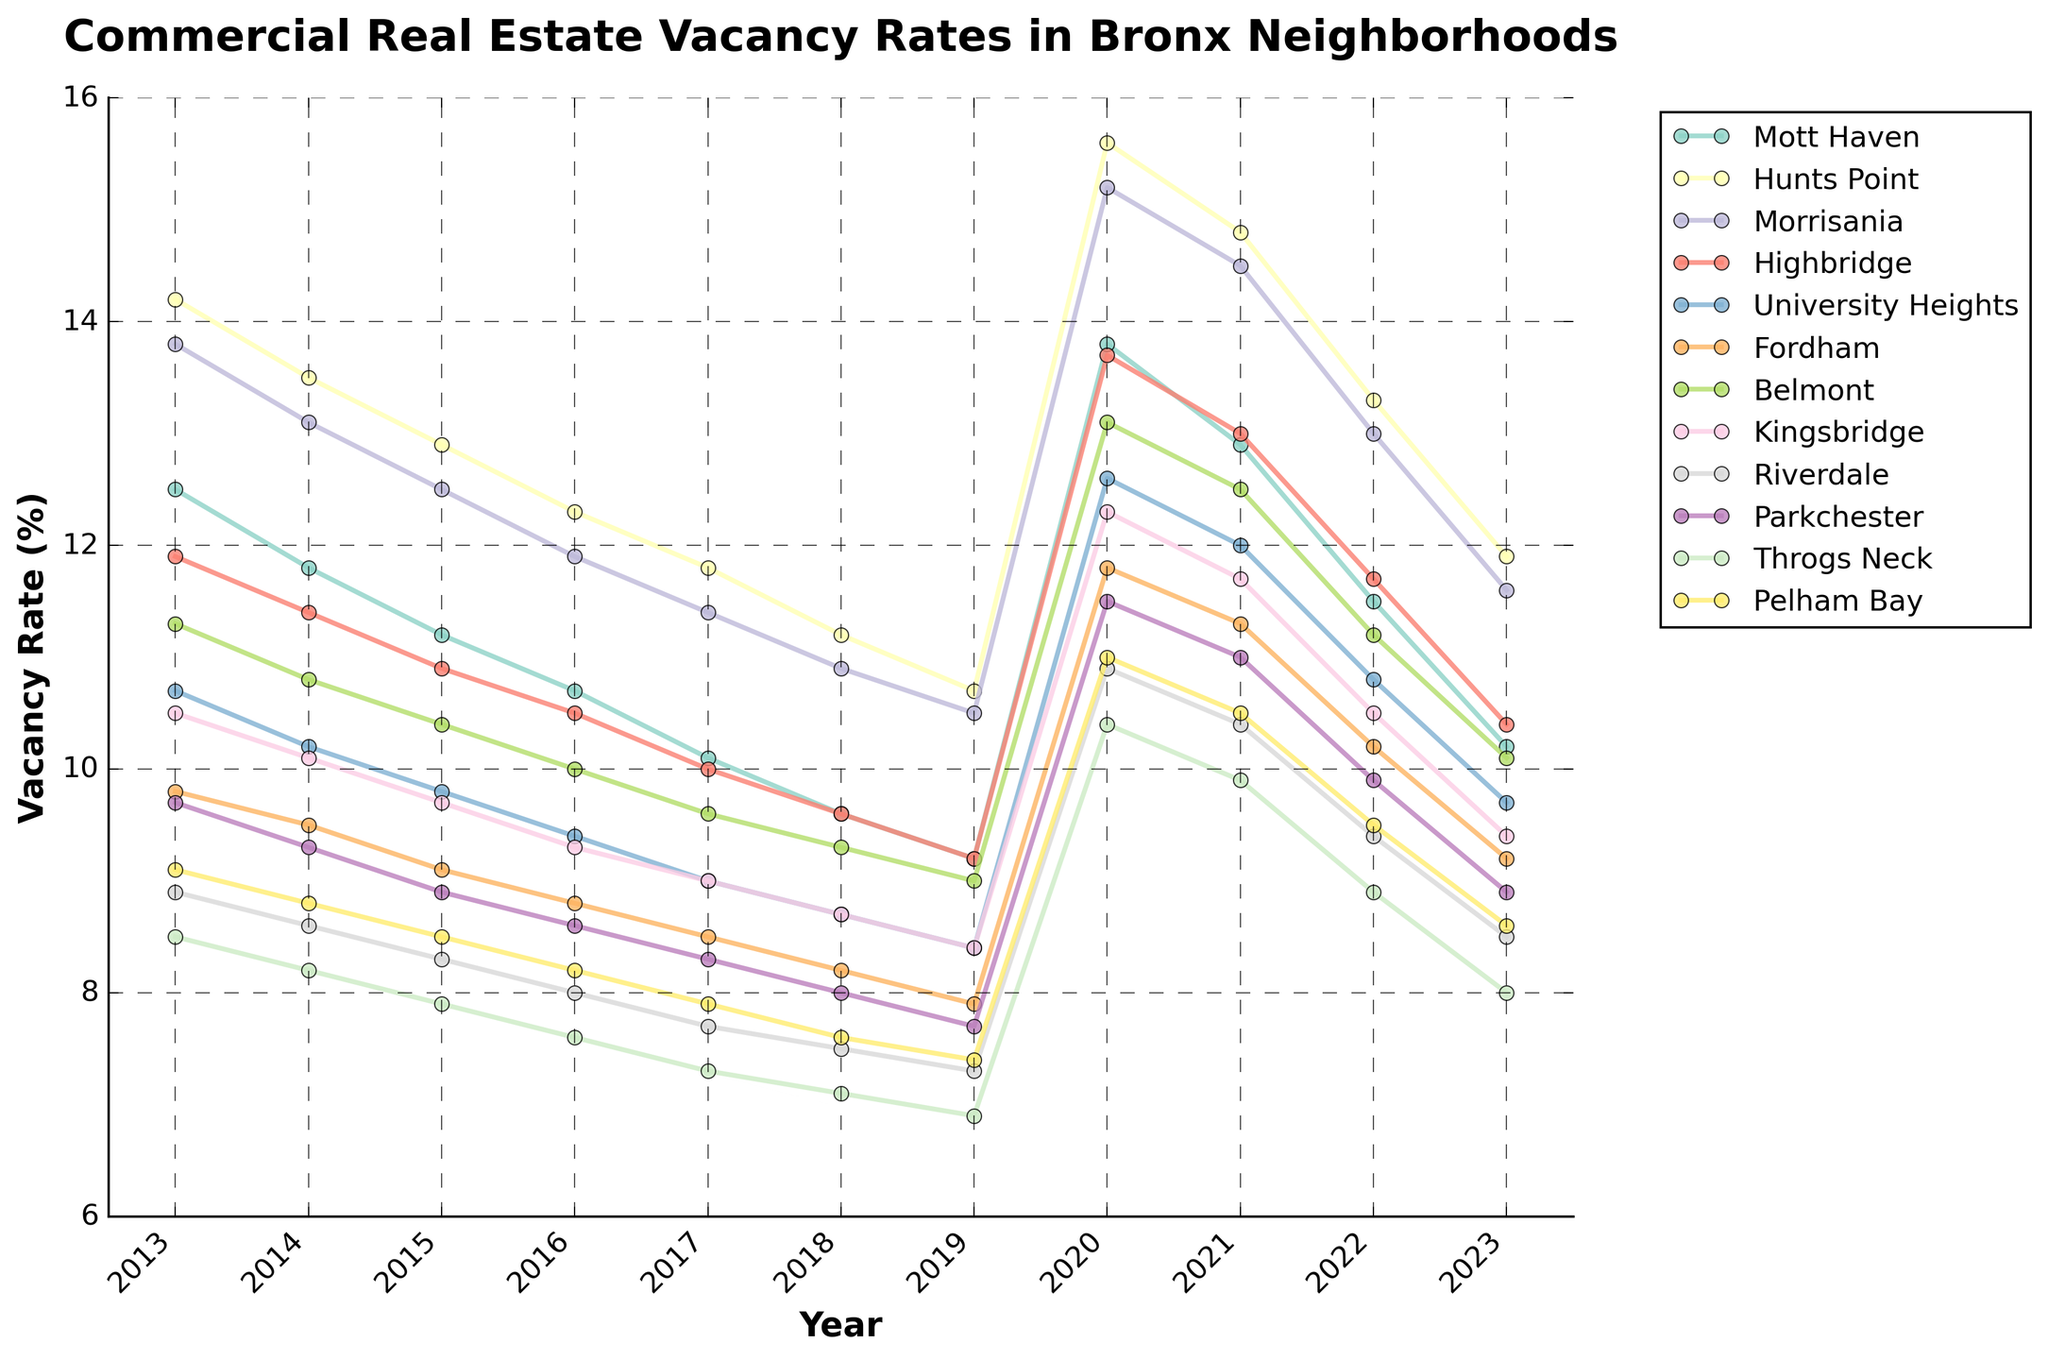Which neighborhood had the highest vacancy rate in 2023? Look for the neighborhood with the highest point on the vertical line corresponding to the year 2023.
Answer: Hunts Point Between which two consecutive years did Mott Haven see the greatest increase in vacancy rate? Determine the difference in vacancy rates for Mott Haven across all consecutive years, then find the pair of years where this difference is the largest positive value. The largest increase was between 2019 and 2020.
Answer: 2019 and 2020 What was the average vacancy rate for Belmont from 2013 to 2023? Sum the values of the Belmont row from 2013 to 2023, then divide by the number of years (11). (11.3 + 10.8 + 10.4 + 10.0 + 9.6 + 9.3 + 9.0 + 13.1 + 12.5 + 11.2 + 10.1) / 11 = 10.67
Answer: 10.67 In which year did University Heights experience the lowest vacancy rate, and what was that rate? Find the lowest point for University Heights line across all years. This occurred in 2017 with a rate of 9.0%.
Answer: 2017, 9.0% How did the vacancy rate trend for Riverdale compare to Kingsbridge between 2020 and 2023? Compare the shapes of the lines for Riverdale and Kingsbridge between the years 2020 and 2023. Both Riverdale and Kingsbridge show a decreasing trend in vacancy rates from 2020 to 2023.
Answer: Both decreased Which neighborhoods had a vacancy rate of 8.0 or lower in 2017? Identify all neighborhoods that have points at or below the 8.0% vacancy rate on the vertical line corresponding to the year 2017. The neighborhoods are Riverdale and Throgs Neck.
Answer: Riverdale and Throgs Neck What is the overall trend in vacancy rates for Pelham Bay from 2013 to 2023? Look at the point progression for Pelham Bay from 2013 to 2023. The trend shows a decrease from 2013 to 2019, an increase in 2020, and then a gradual decrease again to 2023.
Answer: Decreasing, then increasing in 2020, and decreasing again Compare the 2020 vacancy rates between Morrisania and Fordham. What is the difference in their rates? Locate the points for Morrisania and Fordham in the year 2020, then subtract Fordham's vacancy rate from Morrisania's. Morrisania had 15.2%, and Fordham had 11.8%, so the difference is 15.2 - 11.8 = 3.4.
Answer: 3.4 Based on the data, which neighborhood had the most significant drop in vacancy rates from 2013 to 2019? Calculate the difference in vacancy rates from 2013 to 2019 for each neighborhood, and find the neighborhood with the largest negative change. Mott Haven's vacancy rate dropped from 12.5 to 9.2, a difference of -3.3, which appears to be a significant drop.
Answer: Mott Haven 